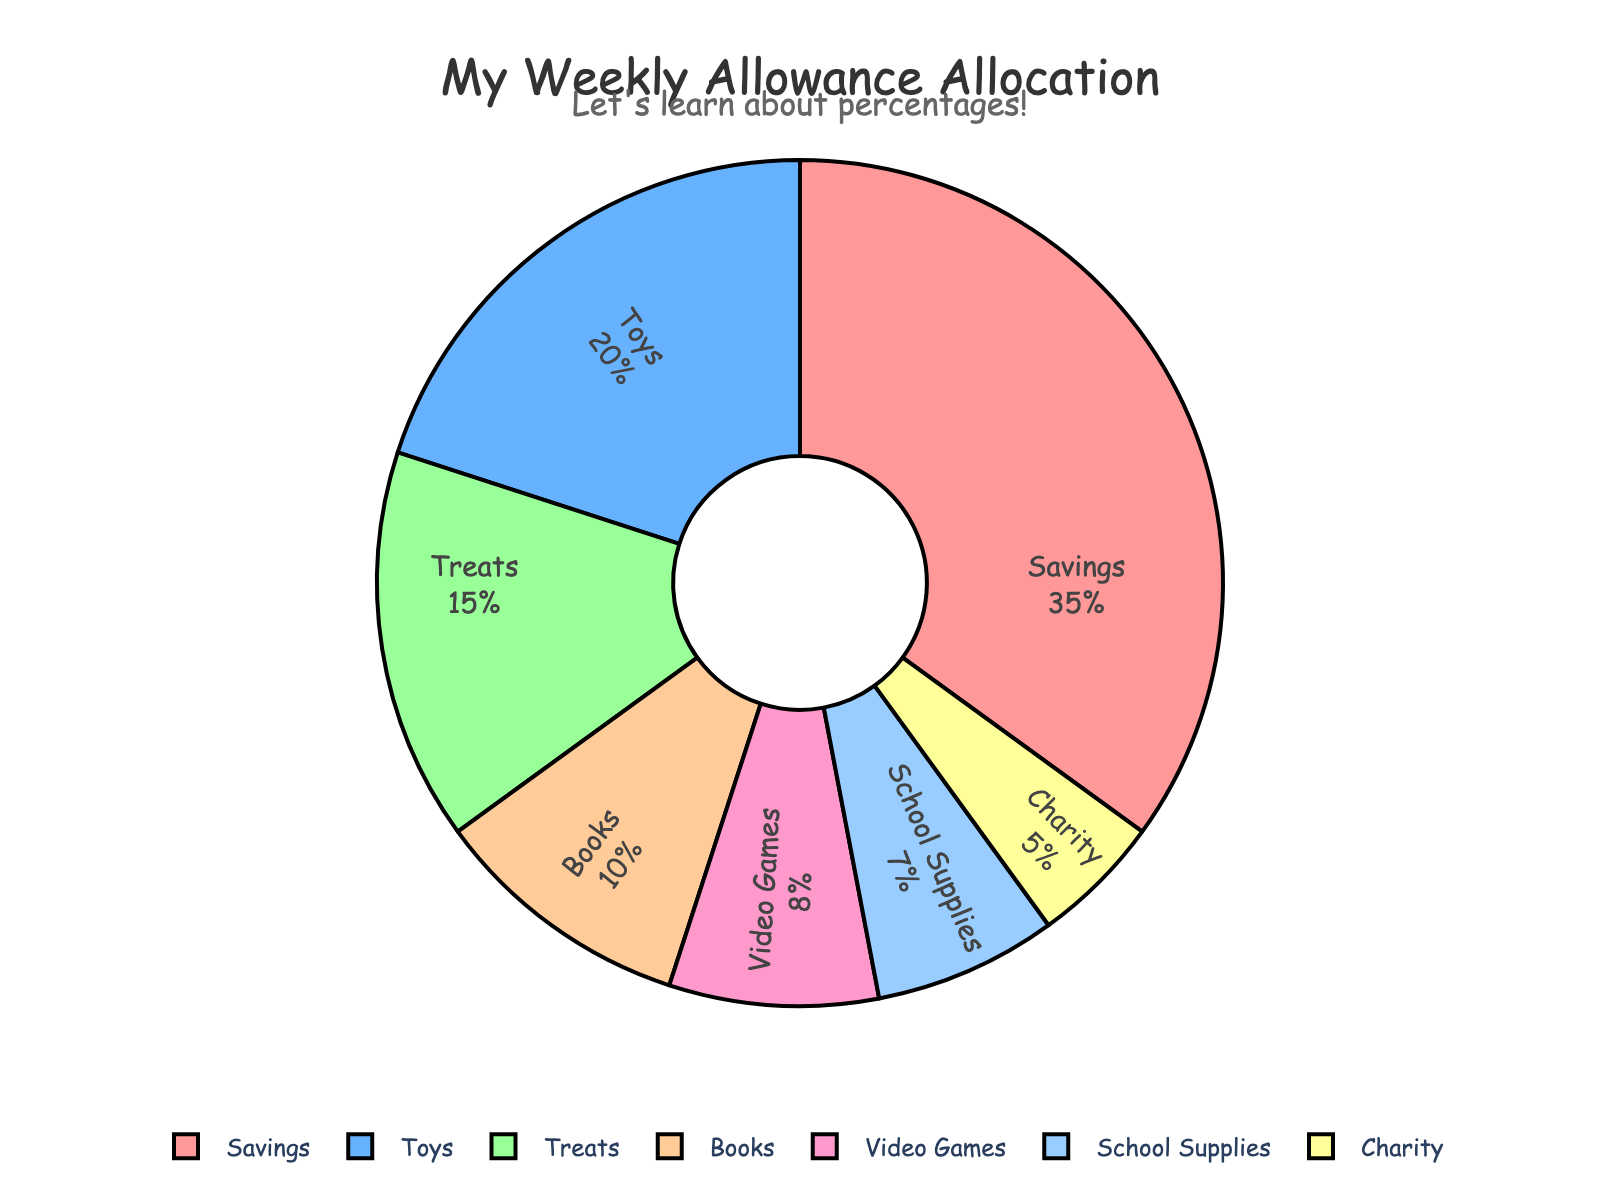What percentage of the weekly allowance is allocated to savings? Look for the slice labeled "Savings" on the pie chart and read the percentage value displayed.
Answer: 35% Which category receives the smallest portion of the weekly allowance? Compare the percentages of all categories on the pie chart. Identify the category with the smallest percentage.
Answer: Charity How much more percentage of the weekly allowance is allocated to toys than to video games? Note the percentages for toys and video games from the chart, then subtract the percentage for video games from the percentage for toys: 20% - 8% = 12%.
Answer: 12% Which category receives the largest portion of the weekly allowance, and what percentage is it? Identify the category with the largest percentage from the pie chart.
Answer: Savings, 35% If you combine the percentages of sheets and school supplies, what fraction of the weekly allowance do they form? Add the percentages of sheets (15%) and school supplies (7%): 15% + 7% = 22%.
Answer: 22% What is the visual color representation of the Books category in the pie chart? Observe the color assigned to the slice labeled "Books" in the pie chart.
Answer: Green How much smaller is the portion for charity compared to savings? Subtract the percentage for charity from the percentage for savings: 35% - 5% = 30%.
Answer: 30% Rank the categories from largest to smallest percentage allocation. List all categories and their respective percentages, then sort them in descending order.
Answer: Savings, Toys, Treats, Books, Video Games, School Supplies, Charity How many categories have a percentage allocation greater than 10%? Count the number of categories on the pie chart that have a percentage greater than 10%: Savings (35%), Toys (20%), Treats (15%), and Books (10%).
Answer: 4 What is the combined percentage of toys, books, and video games? Add the percentage values for toys, books, and video games: 20% + 10% + 8% = 38%.
Answer: 38% 